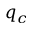<formula> <loc_0><loc_0><loc_500><loc_500>q _ { c }</formula> 